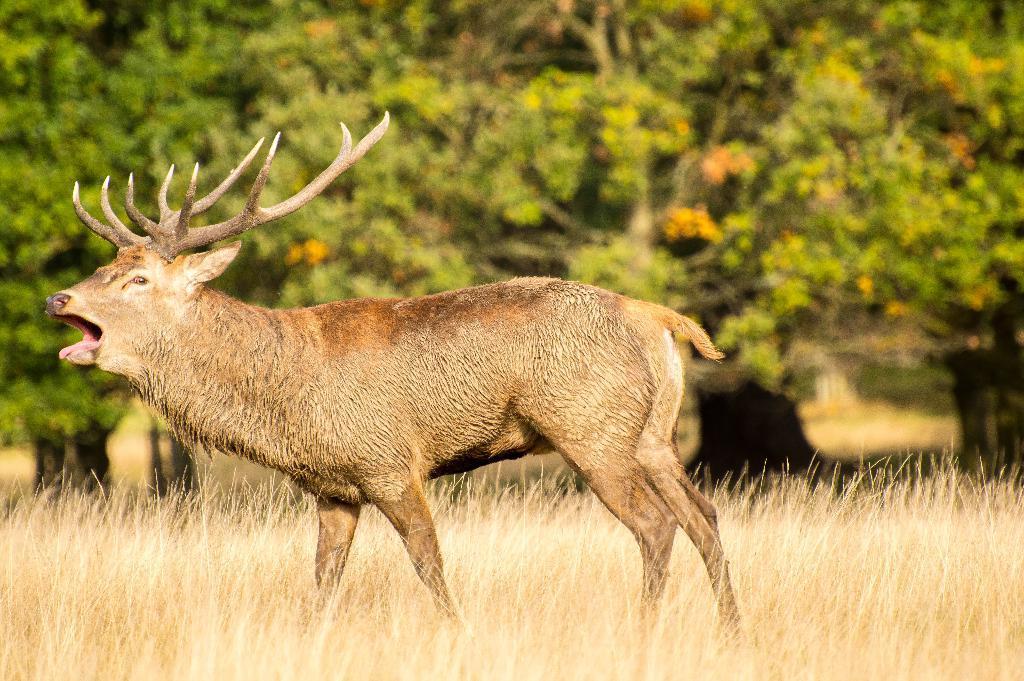Could you give a brief overview of what you see in this image? This picture might be taken from forest. In this image, in the middle, we can see an animal. In the background, we can see some trees, at the bottom there is a grass. 